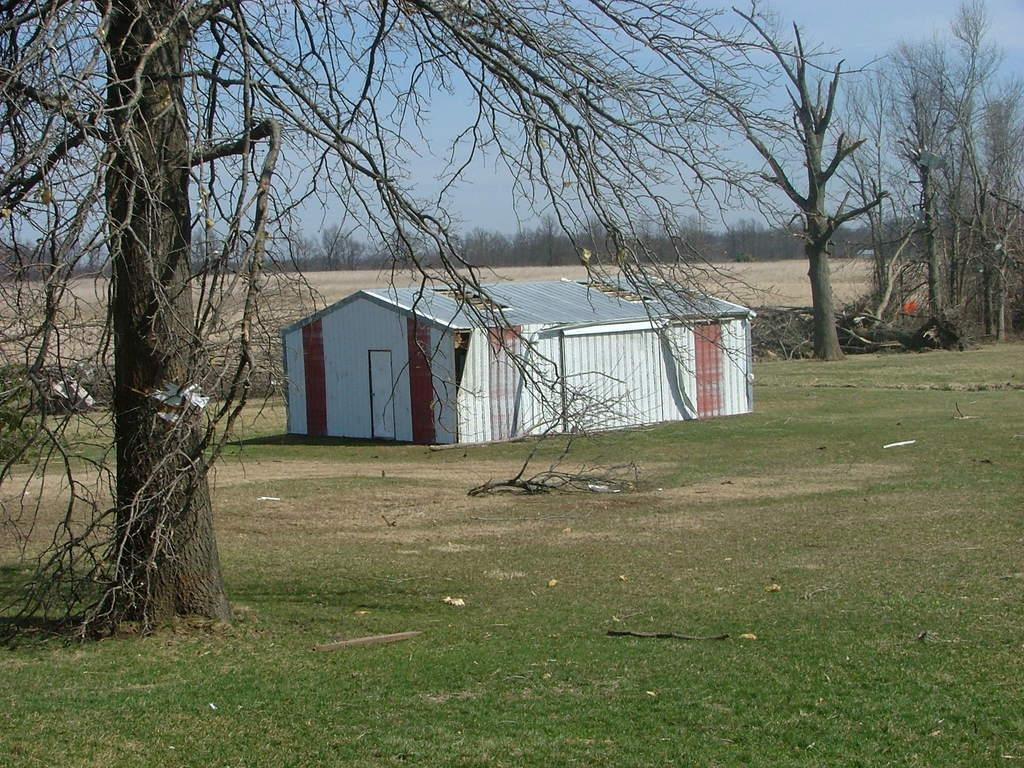What type of vegetation is present in the image? There is grass in the image. Are there any other natural elements in the image? Yes, there are trees in the image. What type of structure can be seen in the image? There is a shed in the image. What is visible in the background of the image? There are trees and the sky visible in the background of the image. Can you describe the maid's uniform in the image? There is no maid present in the image, so it is not possible to describe a maid's uniform. What type of kitten can be seen playing with a gun in the image? There is no kitten or gun present in the image, and therefore no such activity can be observed. 